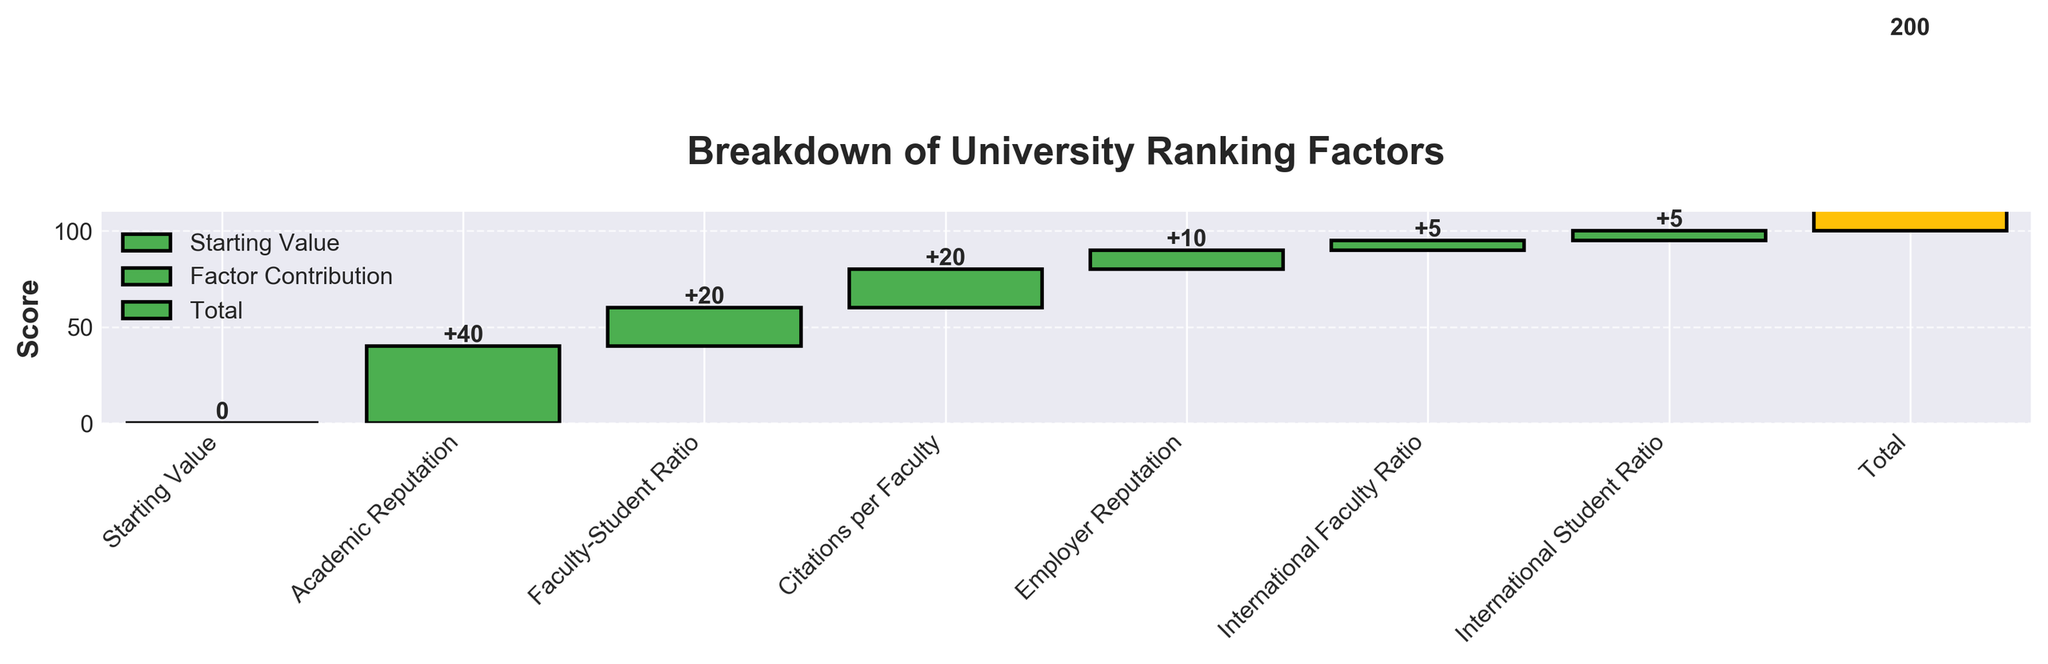What's the title of the chart? The title of the chart is located at the top center and is typically in a larger, bold font to capture attention. In this case, from examining the content, the title is 'Breakdown of University Ranking Factors'.
Answer: Breakdown of University Ranking Factors How many categories are displayed in the chart, excluding the starting value and total? To determine the number of categories displayed, we exclude the 'Starting Value' and 'Total' from the list of categories. Therefore, we count: Academic Reputation, Faculty-Student Ratio, Citations per Faculty, Employer Reputation, International Faculty Ratio, and International Student Ratio, which makes 6 categories in total.
Answer: 6 What is the highest contributing factor to the university ranking? By examining the heights of the bars representing different categories, we identify the highest contributing factor. From the chart, 'Academic Reputation' has the tallest bar, indicating it is the highest contributing factor.
Answer: Academic Reputation What is the combined contribution of Faculty-Student Ratio and Citations per Faculty? To find the combined contribution, we sum up the contributions from Faculty-Student Ratio and Citations per Faculty. Both have a value of 20: 20 + 20 = 40.
Answer: 40 How does International Faculty Ratio compare to International Student Ratio in terms of contribution? By comparing the heights of the bars for these two categories, we can see that both International Faculty Ratio and International Student Ratio have equal contributions (both are 5).
Answer: Equal What is the score just before adding the International Faculty Ratio? To find the score just before adding the International Faculty Ratio, we look at the cumulative score before this value is added. The order is: Academic Reputation (40), Faculty-Student Ratio (20), Citations per Faculty (20), and Employer Reputation (10). Their cumulative score is: 40 + 20 + 20 + 10 = 90.
Answer: 90 How much does Employer Reputation contribute to the total score? By looking at the height of the bar corresponding to Employer Reputation in the waterfall chart, we see the contribution is represented by a numerical label as '10'.
Answer: 10 Which variable contributes least to the score? By examining the smallest bars, we can see which variable contributes the least. Both International Faculty Ratio and International Student Ratio contribute the smallest values, which are 5 each.
Answer: International Faculty Ratio; International Student Ratio By how much would the total score increase if the Faculty-Student Ratio was improved by 10 points? The Faculty-Student Ratio contributes 20 points currently. If it were improved by 10 points, it would contribute 20 + 10 = 30 points. Adding this to the original total score (100), the revised total score would be: 100 + 10 = 110.
Answer: 110 What is the score after including both Academic Reputation and Faculty-Student Ratio? Adding the contributions from Academic Reputation (40) and Faculty-Student Ratio (20), we get: 40 + 20 = 60. The score after including both these factors would be 60.
Answer: 60 